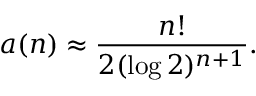<formula> <loc_0><loc_0><loc_500><loc_500>a ( n ) \approx { \frac { n ! } { 2 ( \log 2 ) ^ { n + 1 } } } .</formula> 